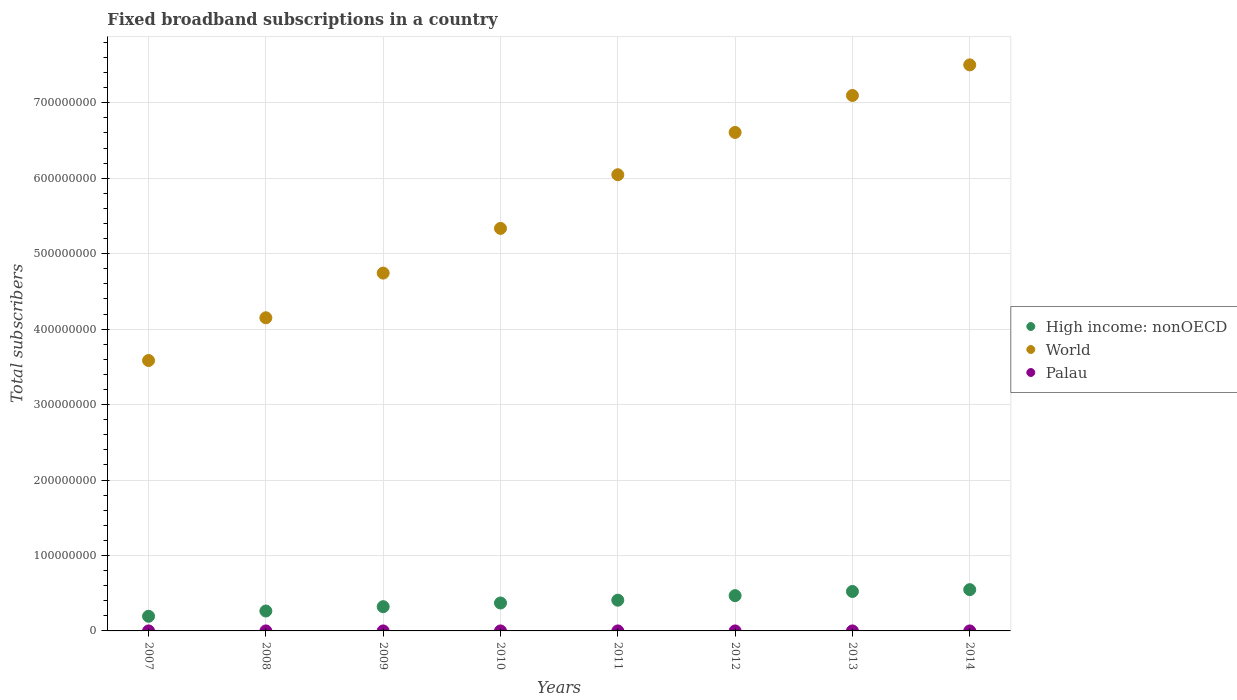What is the number of broadband subscriptions in World in 2011?
Provide a succinct answer. 6.05e+08. Across all years, what is the maximum number of broadband subscriptions in Palau?
Give a very brief answer. 1974. Across all years, what is the minimum number of broadband subscriptions in Palau?
Offer a terse response. 101. In which year was the number of broadband subscriptions in Palau maximum?
Give a very brief answer. 2014. What is the total number of broadband subscriptions in Palau in the graph?
Your response must be concise. 5788. What is the difference between the number of broadband subscriptions in World in 2011 and that in 2014?
Provide a short and direct response. -1.46e+08. What is the difference between the number of broadband subscriptions in World in 2007 and the number of broadband subscriptions in High income: nonOECD in 2009?
Ensure brevity in your answer.  3.26e+08. What is the average number of broadband subscriptions in Palau per year?
Keep it short and to the point. 723.5. In the year 2014, what is the difference between the number of broadband subscriptions in High income: nonOECD and number of broadband subscriptions in Palau?
Provide a short and direct response. 5.47e+07. What is the ratio of the number of broadband subscriptions in World in 2012 to that in 2014?
Your response must be concise. 0.88. What is the difference between the highest and the second highest number of broadband subscriptions in High income: nonOECD?
Provide a short and direct response. 2.42e+06. What is the difference between the highest and the lowest number of broadband subscriptions in Palau?
Your response must be concise. 1873. How many dotlines are there?
Your response must be concise. 3. How many years are there in the graph?
Keep it short and to the point. 8. Does the graph contain any zero values?
Give a very brief answer. No. Where does the legend appear in the graph?
Your response must be concise. Center right. How many legend labels are there?
Make the answer very short. 3. What is the title of the graph?
Provide a short and direct response. Fixed broadband subscriptions in a country. What is the label or title of the Y-axis?
Provide a short and direct response. Total subscribers. What is the Total subscribers in High income: nonOECD in 2007?
Offer a very short reply. 1.94e+07. What is the Total subscribers in World in 2007?
Provide a succinct answer. 3.58e+08. What is the Total subscribers in Palau in 2007?
Offer a terse response. 101. What is the Total subscribers of High income: nonOECD in 2008?
Your answer should be compact. 2.64e+07. What is the Total subscribers of World in 2008?
Give a very brief answer. 4.15e+08. What is the Total subscribers in Palau in 2008?
Keep it short and to the point. 111. What is the Total subscribers in High income: nonOECD in 2009?
Keep it short and to the point. 3.21e+07. What is the Total subscribers of World in 2009?
Your response must be concise. 4.74e+08. What is the Total subscribers of Palau in 2009?
Give a very brief answer. 142. What is the Total subscribers in High income: nonOECD in 2010?
Keep it short and to the point. 3.70e+07. What is the Total subscribers of World in 2010?
Ensure brevity in your answer.  5.33e+08. What is the Total subscribers in Palau in 2010?
Your answer should be compact. 239. What is the Total subscribers of High income: nonOECD in 2011?
Provide a succinct answer. 4.07e+07. What is the Total subscribers of World in 2011?
Make the answer very short. 6.05e+08. What is the Total subscribers in Palau in 2011?
Make the answer very short. 518. What is the Total subscribers of High income: nonOECD in 2012?
Provide a succinct answer. 4.67e+07. What is the Total subscribers of World in 2012?
Provide a short and direct response. 6.61e+08. What is the Total subscribers of Palau in 2012?
Provide a succinct answer. 898. What is the Total subscribers in High income: nonOECD in 2013?
Your response must be concise. 5.23e+07. What is the Total subscribers of World in 2013?
Provide a short and direct response. 7.10e+08. What is the Total subscribers of Palau in 2013?
Make the answer very short. 1805. What is the Total subscribers of High income: nonOECD in 2014?
Make the answer very short. 5.47e+07. What is the Total subscribers of World in 2014?
Ensure brevity in your answer.  7.50e+08. What is the Total subscribers of Palau in 2014?
Provide a succinct answer. 1974. Across all years, what is the maximum Total subscribers of High income: nonOECD?
Offer a very short reply. 5.47e+07. Across all years, what is the maximum Total subscribers in World?
Your answer should be compact. 7.50e+08. Across all years, what is the maximum Total subscribers of Palau?
Offer a terse response. 1974. Across all years, what is the minimum Total subscribers of High income: nonOECD?
Offer a terse response. 1.94e+07. Across all years, what is the minimum Total subscribers of World?
Provide a short and direct response. 3.58e+08. Across all years, what is the minimum Total subscribers of Palau?
Keep it short and to the point. 101. What is the total Total subscribers of High income: nonOECD in the graph?
Offer a very short reply. 3.09e+08. What is the total Total subscribers of World in the graph?
Your response must be concise. 4.51e+09. What is the total Total subscribers in Palau in the graph?
Offer a terse response. 5788. What is the difference between the Total subscribers of High income: nonOECD in 2007 and that in 2008?
Your answer should be very brief. -6.99e+06. What is the difference between the Total subscribers of World in 2007 and that in 2008?
Offer a terse response. -5.66e+07. What is the difference between the Total subscribers of High income: nonOECD in 2007 and that in 2009?
Offer a very short reply. -1.27e+07. What is the difference between the Total subscribers in World in 2007 and that in 2009?
Your answer should be compact. -1.16e+08. What is the difference between the Total subscribers in Palau in 2007 and that in 2009?
Give a very brief answer. -41. What is the difference between the Total subscribers of High income: nonOECD in 2007 and that in 2010?
Provide a succinct answer. -1.76e+07. What is the difference between the Total subscribers in World in 2007 and that in 2010?
Your response must be concise. -1.75e+08. What is the difference between the Total subscribers in Palau in 2007 and that in 2010?
Your response must be concise. -138. What is the difference between the Total subscribers of High income: nonOECD in 2007 and that in 2011?
Provide a succinct answer. -2.13e+07. What is the difference between the Total subscribers of World in 2007 and that in 2011?
Provide a succinct answer. -2.46e+08. What is the difference between the Total subscribers in Palau in 2007 and that in 2011?
Provide a succinct answer. -417. What is the difference between the Total subscribers of High income: nonOECD in 2007 and that in 2012?
Offer a terse response. -2.73e+07. What is the difference between the Total subscribers of World in 2007 and that in 2012?
Provide a succinct answer. -3.02e+08. What is the difference between the Total subscribers of Palau in 2007 and that in 2012?
Give a very brief answer. -797. What is the difference between the Total subscribers in High income: nonOECD in 2007 and that in 2013?
Give a very brief answer. -3.29e+07. What is the difference between the Total subscribers of World in 2007 and that in 2013?
Provide a succinct answer. -3.51e+08. What is the difference between the Total subscribers of Palau in 2007 and that in 2013?
Your response must be concise. -1704. What is the difference between the Total subscribers of High income: nonOECD in 2007 and that in 2014?
Your answer should be compact. -3.53e+07. What is the difference between the Total subscribers of World in 2007 and that in 2014?
Offer a very short reply. -3.92e+08. What is the difference between the Total subscribers of Palau in 2007 and that in 2014?
Your answer should be very brief. -1873. What is the difference between the Total subscribers of High income: nonOECD in 2008 and that in 2009?
Make the answer very short. -5.73e+06. What is the difference between the Total subscribers of World in 2008 and that in 2009?
Your response must be concise. -5.92e+07. What is the difference between the Total subscribers in Palau in 2008 and that in 2009?
Make the answer very short. -31. What is the difference between the Total subscribers in High income: nonOECD in 2008 and that in 2010?
Make the answer very short. -1.06e+07. What is the difference between the Total subscribers in World in 2008 and that in 2010?
Your answer should be very brief. -1.18e+08. What is the difference between the Total subscribers of Palau in 2008 and that in 2010?
Give a very brief answer. -128. What is the difference between the Total subscribers in High income: nonOECD in 2008 and that in 2011?
Your answer should be compact. -1.43e+07. What is the difference between the Total subscribers in World in 2008 and that in 2011?
Give a very brief answer. -1.90e+08. What is the difference between the Total subscribers of Palau in 2008 and that in 2011?
Ensure brevity in your answer.  -407. What is the difference between the Total subscribers in High income: nonOECD in 2008 and that in 2012?
Offer a very short reply. -2.03e+07. What is the difference between the Total subscribers in World in 2008 and that in 2012?
Give a very brief answer. -2.46e+08. What is the difference between the Total subscribers in Palau in 2008 and that in 2012?
Ensure brevity in your answer.  -787. What is the difference between the Total subscribers in High income: nonOECD in 2008 and that in 2013?
Your answer should be very brief. -2.59e+07. What is the difference between the Total subscribers in World in 2008 and that in 2013?
Ensure brevity in your answer.  -2.95e+08. What is the difference between the Total subscribers of Palau in 2008 and that in 2013?
Offer a terse response. -1694. What is the difference between the Total subscribers of High income: nonOECD in 2008 and that in 2014?
Your answer should be compact. -2.83e+07. What is the difference between the Total subscribers in World in 2008 and that in 2014?
Offer a very short reply. -3.35e+08. What is the difference between the Total subscribers in Palau in 2008 and that in 2014?
Make the answer very short. -1863. What is the difference between the Total subscribers in High income: nonOECD in 2009 and that in 2010?
Make the answer very short. -4.88e+06. What is the difference between the Total subscribers of World in 2009 and that in 2010?
Offer a very short reply. -5.92e+07. What is the difference between the Total subscribers in Palau in 2009 and that in 2010?
Make the answer very short. -97. What is the difference between the Total subscribers in High income: nonOECD in 2009 and that in 2011?
Your answer should be compact. -8.60e+06. What is the difference between the Total subscribers in World in 2009 and that in 2011?
Offer a very short reply. -1.30e+08. What is the difference between the Total subscribers in Palau in 2009 and that in 2011?
Provide a succinct answer. -376. What is the difference between the Total subscribers of High income: nonOECD in 2009 and that in 2012?
Keep it short and to the point. -1.46e+07. What is the difference between the Total subscribers of World in 2009 and that in 2012?
Offer a terse response. -1.86e+08. What is the difference between the Total subscribers of Palau in 2009 and that in 2012?
Give a very brief answer. -756. What is the difference between the Total subscribers of High income: nonOECD in 2009 and that in 2013?
Keep it short and to the point. -2.02e+07. What is the difference between the Total subscribers of World in 2009 and that in 2013?
Give a very brief answer. -2.35e+08. What is the difference between the Total subscribers of Palau in 2009 and that in 2013?
Your answer should be compact. -1663. What is the difference between the Total subscribers of High income: nonOECD in 2009 and that in 2014?
Make the answer very short. -2.26e+07. What is the difference between the Total subscribers of World in 2009 and that in 2014?
Your response must be concise. -2.76e+08. What is the difference between the Total subscribers in Palau in 2009 and that in 2014?
Provide a short and direct response. -1832. What is the difference between the Total subscribers in High income: nonOECD in 2010 and that in 2011?
Offer a terse response. -3.72e+06. What is the difference between the Total subscribers in World in 2010 and that in 2011?
Offer a terse response. -7.11e+07. What is the difference between the Total subscribers of Palau in 2010 and that in 2011?
Your answer should be very brief. -279. What is the difference between the Total subscribers of High income: nonOECD in 2010 and that in 2012?
Offer a very short reply. -9.74e+06. What is the difference between the Total subscribers of World in 2010 and that in 2012?
Make the answer very short. -1.27e+08. What is the difference between the Total subscribers of Palau in 2010 and that in 2012?
Give a very brief answer. -659. What is the difference between the Total subscribers in High income: nonOECD in 2010 and that in 2013?
Offer a terse response. -1.53e+07. What is the difference between the Total subscribers in World in 2010 and that in 2013?
Provide a succinct answer. -1.76e+08. What is the difference between the Total subscribers in Palau in 2010 and that in 2013?
Provide a short and direct response. -1566. What is the difference between the Total subscribers of High income: nonOECD in 2010 and that in 2014?
Keep it short and to the point. -1.77e+07. What is the difference between the Total subscribers of World in 2010 and that in 2014?
Your response must be concise. -2.17e+08. What is the difference between the Total subscribers in Palau in 2010 and that in 2014?
Keep it short and to the point. -1735. What is the difference between the Total subscribers in High income: nonOECD in 2011 and that in 2012?
Ensure brevity in your answer.  -6.02e+06. What is the difference between the Total subscribers in World in 2011 and that in 2012?
Your answer should be compact. -5.61e+07. What is the difference between the Total subscribers of Palau in 2011 and that in 2012?
Keep it short and to the point. -380. What is the difference between the Total subscribers of High income: nonOECD in 2011 and that in 2013?
Ensure brevity in your answer.  -1.16e+07. What is the difference between the Total subscribers of World in 2011 and that in 2013?
Your response must be concise. -1.05e+08. What is the difference between the Total subscribers in Palau in 2011 and that in 2013?
Provide a succinct answer. -1287. What is the difference between the Total subscribers in High income: nonOECD in 2011 and that in 2014?
Provide a succinct answer. -1.40e+07. What is the difference between the Total subscribers of World in 2011 and that in 2014?
Offer a terse response. -1.46e+08. What is the difference between the Total subscribers in Palau in 2011 and that in 2014?
Make the answer very short. -1456. What is the difference between the Total subscribers in High income: nonOECD in 2012 and that in 2013?
Offer a terse response. -5.55e+06. What is the difference between the Total subscribers in World in 2012 and that in 2013?
Your answer should be very brief. -4.90e+07. What is the difference between the Total subscribers of Palau in 2012 and that in 2013?
Ensure brevity in your answer.  -907. What is the difference between the Total subscribers in High income: nonOECD in 2012 and that in 2014?
Offer a very short reply. -7.97e+06. What is the difference between the Total subscribers in World in 2012 and that in 2014?
Ensure brevity in your answer.  -8.95e+07. What is the difference between the Total subscribers of Palau in 2012 and that in 2014?
Provide a succinct answer. -1076. What is the difference between the Total subscribers in High income: nonOECD in 2013 and that in 2014?
Your response must be concise. -2.42e+06. What is the difference between the Total subscribers of World in 2013 and that in 2014?
Offer a terse response. -4.05e+07. What is the difference between the Total subscribers of Palau in 2013 and that in 2014?
Offer a terse response. -169. What is the difference between the Total subscribers in High income: nonOECD in 2007 and the Total subscribers in World in 2008?
Offer a very short reply. -3.96e+08. What is the difference between the Total subscribers in High income: nonOECD in 2007 and the Total subscribers in Palau in 2008?
Offer a terse response. 1.94e+07. What is the difference between the Total subscribers of World in 2007 and the Total subscribers of Palau in 2008?
Make the answer very short. 3.58e+08. What is the difference between the Total subscribers in High income: nonOECD in 2007 and the Total subscribers in World in 2009?
Keep it short and to the point. -4.55e+08. What is the difference between the Total subscribers of High income: nonOECD in 2007 and the Total subscribers of Palau in 2009?
Your response must be concise. 1.94e+07. What is the difference between the Total subscribers of World in 2007 and the Total subscribers of Palau in 2009?
Provide a succinct answer. 3.58e+08. What is the difference between the Total subscribers of High income: nonOECD in 2007 and the Total subscribers of World in 2010?
Provide a short and direct response. -5.14e+08. What is the difference between the Total subscribers in High income: nonOECD in 2007 and the Total subscribers in Palau in 2010?
Ensure brevity in your answer.  1.94e+07. What is the difference between the Total subscribers of World in 2007 and the Total subscribers of Palau in 2010?
Your answer should be compact. 3.58e+08. What is the difference between the Total subscribers in High income: nonOECD in 2007 and the Total subscribers in World in 2011?
Provide a short and direct response. -5.85e+08. What is the difference between the Total subscribers in High income: nonOECD in 2007 and the Total subscribers in Palau in 2011?
Give a very brief answer. 1.94e+07. What is the difference between the Total subscribers of World in 2007 and the Total subscribers of Palau in 2011?
Your answer should be very brief. 3.58e+08. What is the difference between the Total subscribers of High income: nonOECD in 2007 and the Total subscribers of World in 2012?
Make the answer very short. -6.41e+08. What is the difference between the Total subscribers of High income: nonOECD in 2007 and the Total subscribers of Palau in 2012?
Ensure brevity in your answer.  1.94e+07. What is the difference between the Total subscribers in World in 2007 and the Total subscribers in Palau in 2012?
Provide a short and direct response. 3.58e+08. What is the difference between the Total subscribers in High income: nonOECD in 2007 and the Total subscribers in World in 2013?
Give a very brief answer. -6.90e+08. What is the difference between the Total subscribers of High income: nonOECD in 2007 and the Total subscribers of Palau in 2013?
Offer a very short reply. 1.94e+07. What is the difference between the Total subscribers in World in 2007 and the Total subscribers in Palau in 2013?
Keep it short and to the point. 3.58e+08. What is the difference between the Total subscribers of High income: nonOECD in 2007 and the Total subscribers of World in 2014?
Provide a succinct answer. -7.31e+08. What is the difference between the Total subscribers of High income: nonOECD in 2007 and the Total subscribers of Palau in 2014?
Offer a very short reply. 1.94e+07. What is the difference between the Total subscribers in World in 2007 and the Total subscribers in Palau in 2014?
Provide a short and direct response. 3.58e+08. What is the difference between the Total subscribers in High income: nonOECD in 2008 and the Total subscribers in World in 2009?
Make the answer very short. -4.48e+08. What is the difference between the Total subscribers of High income: nonOECD in 2008 and the Total subscribers of Palau in 2009?
Offer a terse response. 2.64e+07. What is the difference between the Total subscribers of World in 2008 and the Total subscribers of Palau in 2009?
Offer a very short reply. 4.15e+08. What is the difference between the Total subscribers of High income: nonOECD in 2008 and the Total subscribers of World in 2010?
Keep it short and to the point. -5.07e+08. What is the difference between the Total subscribers in High income: nonOECD in 2008 and the Total subscribers in Palau in 2010?
Offer a very short reply. 2.64e+07. What is the difference between the Total subscribers of World in 2008 and the Total subscribers of Palau in 2010?
Ensure brevity in your answer.  4.15e+08. What is the difference between the Total subscribers in High income: nonOECD in 2008 and the Total subscribers in World in 2011?
Your answer should be compact. -5.78e+08. What is the difference between the Total subscribers in High income: nonOECD in 2008 and the Total subscribers in Palau in 2011?
Your response must be concise. 2.64e+07. What is the difference between the Total subscribers of World in 2008 and the Total subscribers of Palau in 2011?
Your response must be concise. 4.15e+08. What is the difference between the Total subscribers of High income: nonOECD in 2008 and the Total subscribers of World in 2012?
Offer a very short reply. -6.34e+08. What is the difference between the Total subscribers in High income: nonOECD in 2008 and the Total subscribers in Palau in 2012?
Your response must be concise. 2.64e+07. What is the difference between the Total subscribers in World in 2008 and the Total subscribers in Palau in 2012?
Provide a succinct answer. 4.15e+08. What is the difference between the Total subscribers in High income: nonOECD in 2008 and the Total subscribers in World in 2013?
Make the answer very short. -6.83e+08. What is the difference between the Total subscribers in High income: nonOECD in 2008 and the Total subscribers in Palau in 2013?
Your response must be concise. 2.64e+07. What is the difference between the Total subscribers of World in 2008 and the Total subscribers of Palau in 2013?
Give a very brief answer. 4.15e+08. What is the difference between the Total subscribers of High income: nonOECD in 2008 and the Total subscribers of World in 2014?
Provide a short and direct response. -7.24e+08. What is the difference between the Total subscribers in High income: nonOECD in 2008 and the Total subscribers in Palau in 2014?
Offer a very short reply. 2.64e+07. What is the difference between the Total subscribers in World in 2008 and the Total subscribers in Palau in 2014?
Keep it short and to the point. 4.15e+08. What is the difference between the Total subscribers of High income: nonOECD in 2009 and the Total subscribers of World in 2010?
Your answer should be compact. -5.01e+08. What is the difference between the Total subscribers of High income: nonOECD in 2009 and the Total subscribers of Palau in 2010?
Give a very brief answer. 3.21e+07. What is the difference between the Total subscribers in World in 2009 and the Total subscribers in Palau in 2010?
Offer a very short reply. 4.74e+08. What is the difference between the Total subscribers of High income: nonOECD in 2009 and the Total subscribers of World in 2011?
Your answer should be compact. -5.72e+08. What is the difference between the Total subscribers of High income: nonOECD in 2009 and the Total subscribers of Palau in 2011?
Your response must be concise. 3.21e+07. What is the difference between the Total subscribers of World in 2009 and the Total subscribers of Palau in 2011?
Your answer should be very brief. 4.74e+08. What is the difference between the Total subscribers of High income: nonOECD in 2009 and the Total subscribers of World in 2012?
Give a very brief answer. -6.29e+08. What is the difference between the Total subscribers in High income: nonOECD in 2009 and the Total subscribers in Palau in 2012?
Your answer should be very brief. 3.21e+07. What is the difference between the Total subscribers of World in 2009 and the Total subscribers of Palau in 2012?
Your answer should be compact. 4.74e+08. What is the difference between the Total subscribers of High income: nonOECD in 2009 and the Total subscribers of World in 2013?
Provide a short and direct response. -6.78e+08. What is the difference between the Total subscribers of High income: nonOECD in 2009 and the Total subscribers of Palau in 2013?
Offer a terse response. 3.21e+07. What is the difference between the Total subscribers of World in 2009 and the Total subscribers of Palau in 2013?
Give a very brief answer. 4.74e+08. What is the difference between the Total subscribers in High income: nonOECD in 2009 and the Total subscribers in World in 2014?
Give a very brief answer. -7.18e+08. What is the difference between the Total subscribers in High income: nonOECD in 2009 and the Total subscribers in Palau in 2014?
Keep it short and to the point. 3.21e+07. What is the difference between the Total subscribers of World in 2009 and the Total subscribers of Palau in 2014?
Your answer should be very brief. 4.74e+08. What is the difference between the Total subscribers in High income: nonOECD in 2010 and the Total subscribers in World in 2011?
Make the answer very short. -5.68e+08. What is the difference between the Total subscribers in High income: nonOECD in 2010 and the Total subscribers in Palau in 2011?
Give a very brief answer. 3.70e+07. What is the difference between the Total subscribers in World in 2010 and the Total subscribers in Palau in 2011?
Provide a succinct answer. 5.33e+08. What is the difference between the Total subscribers of High income: nonOECD in 2010 and the Total subscribers of World in 2012?
Provide a succinct answer. -6.24e+08. What is the difference between the Total subscribers in High income: nonOECD in 2010 and the Total subscribers in Palau in 2012?
Offer a terse response. 3.70e+07. What is the difference between the Total subscribers in World in 2010 and the Total subscribers in Palau in 2012?
Your answer should be compact. 5.33e+08. What is the difference between the Total subscribers in High income: nonOECD in 2010 and the Total subscribers in World in 2013?
Your answer should be compact. -6.73e+08. What is the difference between the Total subscribers of High income: nonOECD in 2010 and the Total subscribers of Palau in 2013?
Offer a terse response. 3.70e+07. What is the difference between the Total subscribers in World in 2010 and the Total subscribers in Palau in 2013?
Offer a very short reply. 5.33e+08. What is the difference between the Total subscribers of High income: nonOECD in 2010 and the Total subscribers of World in 2014?
Offer a terse response. -7.13e+08. What is the difference between the Total subscribers of High income: nonOECD in 2010 and the Total subscribers of Palau in 2014?
Your response must be concise. 3.70e+07. What is the difference between the Total subscribers of World in 2010 and the Total subscribers of Palau in 2014?
Keep it short and to the point. 5.33e+08. What is the difference between the Total subscribers in High income: nonOECD in 2011 and the Total subscribers in World in 2012?
Ensure brevity in your answer.  -6.20e+08. What is the difference between the Total subscribers of High income: nonOECD in 2011 and the Total subscribers of Palau in 2012?
Ensure brevity in your answer.  4.07e+07. What is the difference between the Total subscribers of World in 2011 and the Total subscribers of Palau in 2012?
Offer a very short reply. 6.05e+08. What is the difference between the Total subscribers of High income: nonOECD in 2011 and the Total subscribers of World in 2013?
Make the answer very short. -6.69e+08. What is the difference between the Total subscribers in High income: nonOECD in 2011 and the Total subscribers in Palau in 2013?
Offer a terse response. 4.07e+07. What is the difference between the Total subscribers in World in 2011 and the Total subscribers in Palau in 2013?
Provide a short and direct response. 6.05e+08. What is the difference between the Total subscribers of High income: nonOECD in 2011 and the Total subscribers of World in 2014?
Provide a short and direct response. -7.09e+08. What is the difference between the Total subscribers of High income: nonOECD in 2011 and the Total subscribers of Palau in 2014?
Make the answer very short. 4.07e+07. What is the difference between the Total subscribers in World in 2011 and the Total subscribers in Palau in 2014?
Your answer should be compact. 6.05e+08. What is the difference between the Total subscribers in High income: nonOECD in 2012 and the Total subscribers in World in 2013?
Ensure brevity in your answer.  -6.63e+08. What is the difference between the Total subscribers of High income: nonOECD in 2012 and the Total subscribers of Palau in 2013?
Provide a short and direct response. 4.67e+07. What is the difference between the Total subscribers of World in 2012 and the Total subscribers of Palau in 2013?
Offer a terse response. 6.61e+08. What is the difference between the Total subscribers in High income: nonOECD in 2012 and the Total subscribers in World in 2014?
Your answer should be compact. -7.03e+08. What is the difference between the Total subscribers in High income: nonOECD in 2012 and the Total subscribers in Palau in 2014?
Offer a terse response. 4.67e+07. What is the difference between the Total subscribers of World in 2012 and the Total subscribers of Palau in 2014?
Ensure brevity in your answer.  6.61e+08. What is the difference between the Total subscribers in High income: nonOECD in 2013 and the Total subscribers in World in 2014?
Your response must be concise. -6.98e+08. What is the difference between the Total subscribers of High income: nonOECD in 2013 and the Total subscribers of Palau in 2014?
Your answer should be very brief. 5.23e+07. What is the difference between the Total subscribers in World in 2013 and the Total subscribers in Palau in 2014?
Offer a terse response. 7.10e+08. What is the average Total subscribers in High income: nonOECD per year?
Provide a short and direct response. 3.87e+07. What is the average Total subscribers in World per year?
Keep it short and to the point. 5.63e+08. What is the average Total subscribers in Palau per year?
Keep it short and to the point. 723.5. In the year 2007, what is the difference between the Total subscribers in High income: nonOECD and Total subscribers in World?
Provide a succinct answer. -3.39e+08. In the year 2007, what is the difference between the Total subscribers of High income: nonOECD and Total subscribers of Palau?
Provide a succinct answer. 1.94e+07. In the year 2007, what is the difference between the Total subscribers of World and Total subscribers of Palau?
Your response must be concise. 3.58e+08. In the year 2008, what is the difference between the Total subscribers of High income: nonOECD and Total subscribers of World?
Your answer should be very brief. -3.89e+08. In the year 2008, what is the difference between the Total subscribers of High income: nonOECD and Total subscribers of Palau?
Give a very brief answer. 2.64e+07. In the year 2008, what is the difference between the Total subscribers in World and Total subscribers in Palau?
Your response must be concise. 4.15e+08. In the year 2009, what is the difference between the Total subscribers of High income: nonOECD and Total subscribers of World?
Make the answer very short. -4.42e+08. In the year 2009, what is the difference between the Total subscribers in High income: nonOECD and Total subscribers in Palau?
Provide a short and direct response. 3.21e+07. In the year 2009, what is the difference between the Total subscribers in World and Total subscribers in Palau?
Your answer should be compact. 4.74e+08. In the year 2010, what is the difference between the Total subscribers of High income: nonOECD and Total subscribers of World?
Give a very brief answer. -4.96e+08. In the year 2010, what is the difference between the Total subscribers of High income: nonOECD and Total subscribers of Palau?
Provide a succinct answer. 3.70e+07. In the year 2010, what is the difference between the Total subscribers in World and Total subscribers in Palau?
Your answer should be very brief. 5.33e+08. In the year 2011, what is the difference between the Total subscribers in High income: nonOECD and Total subscribers in World?
Ensure brevity in your answer.  -5.64e+08. In the year 2011, what is the difference between the Total subscribers of High income: nonOECD and Total subscribers of Palau?
Provide a short and direct response. 4.07e+07. In the year 2011, what is the difference between the Total subscribers in World and Total subscribers in Palau?
Offer a terse response. 6.05e+08. In the year 2012, what is the difference between the Total subscribers of High income: nonOECD and Total subscribers of World?
Keep it short and to the point. -6.14e+08. In the year 2012, what is the difference between the Total subscribers in High income: nonOECD and Total subscribers in Palau?
Your answer should be compact. 4.67e+07. In the year 2012, what is the difference between the Total subscribers in World and Total subscribers in Palau?
Offer a terse response. 6.61e+08. In the year 2013, what is the difference between the Total subscribers in High income: nonOECD and Total subscribers in World?
Provide a short and direct response. -6.57e+08. In the year 2013, what is the difference between the Total subscribers in High income: nonOECD and Total subscribers in Palau?
Your answer should be compact. 5.23e+07. In the year 2013, what is the difference between the Total subscribers in World and Total subscribers in Palau?
Make the answer very short. 7.10e+08. In the year 2014, what is the difference between the Total subscribers of High income: nonOECD and Total subscribers of World?
Give a very brief answer. -6.95e+08. In the year 2014, what is the difference between the Total subscribers in High income: nonOECD and Total subscribers in Palau?
Provide a succinct answer. 5.47e+07. In the year 2014, what is the difference between the Total subscribers in World and Total subscribers in Palau?
Provide a succinct answer. 7.50e+08. What is the ratio of the Total subscribers in High income: nonOECD in 2007 to that in 2008?
Keep it short and to the point. 0.74. What is the ratio of the Total subscribers in World in 2007 to that in 2008?
Offer a terse response. 0.86. What is the ratio of the Total subscribers of Palau in 2007 to that in 2008?
Provide a succinct answer. 0.91. What is the ratio of the Total subscribers in High income: nonOECD in 2007 to that in 2009?
Your answer should be compact. 0.6. What is the ratio of the Total subscribers in World in 2007 to that in 2009?
Provide a succinct answer. 0.76. What is the ratio of the Total subscribers of Palau in 2007 to that in 2009?
Make the answer very short. 0.71. What is the ratio of the Total subscribers in High income: nonOECD in 2007 to that in 2010?
Offer a very short reply. 0.52. What is the ratio of the Total subscribers of World in 2007 to that in 2010?
Your answer should be very brief. 0.67. What is the ratio of the Total subscribers in Palau in 2007 to that in 2010?
Your answer should be compact. 0.42. What is the ratio of the Total subscribers of High income: nonOECD in 2007 to that in 2011?
Provide a succinct answer. 0.48. What is the ratio of the Total subscribers in World in 2007 to that in 2011?
Your answer should be compact. 0.59. What is the ratio of the Total subscribers in Palau in 2007 to that in 2011?
Ensure brevity in your answer.  0.2. What is the ratio of the Total subscribers of High income: nonOECD in 2007 to that in 2012?
Your answer should be compact. 0.42. What is the ratio of the Total subscribers of World in 2007 to that in 2012?
Give a very brief answer. 0.54. What is the ratio of the Total subscribers in Palau in 2007 to that in 2012?
Offer a terse response. 0.11. What is the ratio of the Total subscribers of High income: nonOECD in 2007 to that in 2013?
Offer a terse response. 0.37. What is the ratio of the Total subscribers in World in 2007 to that in 2013?
Provide a succinct answer. 0.51. What is the ratio of the Total subscribers of Palau in 2007 to that in 2013?
Your answer should be very brief. 0.06. What is the ratio of the Total subscribers of High income: nonOECD in 2007 to that in 2014?
Your answer should be compact. 0.35. What is the ratio of the Total subscribers in World in 2007 to that in 2014?
Provide a short and direct response. 0.48. What is the ratio of the Total subscribers in Palau in 2007 to that in 2014?
Your response must be concise. 0.05. What is the ratio of the Total subscribers of High income: nonOECD in 2008 to that in 2009?
Your response must be concise. 0.82. What is the ratio of the Total subscribers in World in 2008 to that in 2009?
Offer a very short reply. 0.88. What is the ratio of the Total subscribers of Palau in 2008 to that in 2009?
Keep it short and to the point. 0.78. What is the ratio of the Total subscribers in High income: nonOECD in 2008 to that in 2010?
Keep it short and to the point. 0.71. What is the ratio of the Total subscribers of World in 2008 to that in 2010?
Your answer should be compact. 0.78. What is the ratio of the Total subscribers of Palau in 2008 to that in 2010?
Offer a very short reply. 0.46. What is the ratio of the Total subscribers in High income: nonOECD in 2008 to that in 2011?
Your answer should be compact. 0.65. What is the ratio of the Total subscribers in World in 2008 to that in 2011?
Offer a very short reply. 0.69. What is the ratio of the Total subscribers of Palau in 2008 to that in 2011?
Provide a short and direct response. 0.21. What is the ratio of the Total subscribers in High income: nonOECD in 2008 to that in 2012?
Make the answer very short. 0.56. What is the ratio of the Total subscribers in World in 2008 to that in 2012?
Ensure brevity in your answer.  0.63. What is the ratio of the Total subscribers of Palau in 2008 to that in 2012?
Make the answer very short. 0.12. What is the ratio of the Total subscribers in High income: nonOECD in 2008 to that in 2013?
Ensure brevity in your answer.  0.5. What is the ratio of the Total subscribers of World in 2008 to that in 2013?
Provide a succinct answer. 0.58. What is the ratio of the Total subscribers of Palau in 2008 to that in 2013?
Keep it short and to the point. 0.06. What is the ratio of the Total subscribers in High income: nonOECD in 2008 to that in 2014?
Offer a terse response. 0.48. What is the ratio of the Total subscribers of World in 2008 to that in 2014?
Provide a succinct answer. 0.55. What is the ratio of the Total subscribers of Palau in 2008 to that in 2014?
Offer a very short reply. 0.06. What is the ratio of the Total subscribers in High income: nonOECD in 2009 to that in 2010?
Make the answer very short. 0.87. What is the ratio of the Total subscribers of World in 2009 to that in 2010?
Your response must be concise. 0.89. What is the ratio of the Total subscribers in Palau in 2009 to that in 2010?
Your answer should be compact. 0.59. What is the ratio of the Total subscribers of High income: nonOECD in 2009 to that in 2011?
Offer a terse response. 0.79. What is the ratio of the Total subscribers in World in 2009 to that in 2011?
Your answer should be very brief. 0.78. What is the ratio of the Total subscribers of Palau in 2009 to that in 2011?
Make the answer very short. 0.27. What is the ratio of the Total subscribers of High income: nonOECD in 2009 to that in 2012?
Offer a terse response. 0.69. What is the ratio of the Total subscribers in World in 2009 to that in 2012?
Your answer should be compact. 0.72. What is the ratio of the Total subscribers in Palau in 2009 to that in 2012?
Give a very brief answer. 0.16. What is the ratio of the Total subscribers of High income: nonOECD in 2009 to that in 2013?
Make the answer very short. 0.61. What is the ratio of the Total subscribers in World in 2009 to that in 2013?
Keep it short and to the point. 0.67. What is the ratio of the Total subscribers in Palau in 2009 to that in 2013?
Your response must be concise. 0.08. What is the ratio of the Total subscribers of High income: nonOECD in 2009 to that in 2014?
Your answer should be compact. 0.59. What is the ratio of the Total subscribers of World in 2009 to that in 2014?
Your answer should be very brief. 0.63. What is the ratio of the Total subscribers of Palau in 2009 to that in 2014?
Your answer should be very brief. 0.07. What is the ratio of the Total subscribers of High income: nonOECD in 2010 to that in 2011?
Provide a succinct answer. 0.91. What is the ratio of the Total subscribers of World in 2010 to that in 2011?
Your answer should be compact. 0.88. What is the ratio of the Total subscribers in Palau in 2010 to that in 2011?
Provide a succinct answer. 0.46. What is the ratio of the Total subscribers in High income: nonOECD in 2010 to that in 2012?
Make the answer very short. 0.79. What is the ratio of the Total subscribers in World in 2010 to that in 2012?
Your answer should be very brief. 0.81. What is the ratio of the Total subscribers in Palau in 2010 to that in 2012?
Provide a short and direct response. 0.27. What is the ratio of the Total subscribers of High income: nonOECD in 2010 to that in 2013?
Ensure brevity in your answer.  0.71. What is the ratio of the Total subscribers of World in 2010 to that in 2013?
Keep it short and to the point. 0.75. What is the ratio of the Total subscribers in Palau in 2010 to that in 2013?
Your answer should be compact. 0.13. What is the ratio of the Total subscribers of High income: nonOECD in 2010 to that in 2014?
Your answer should be very brief. 0.68. What is the ratio of the Total subscribers of World in 2010 to that in 2014?
Ensure brevity in your answer.  0.71. What is the ratio of the Total subscribers in Palau in 2010 to that in 2014?
Make the answer very short. 0.12. What is the ratio of the Total subscribers in High income: nonOECD in 2011 to that in 2012?
Offer a terse response. 0.87. What is the ratio of the Total subscribers of World in 2011 to that in 2012?
Provide a short and direct response. 0.92. What is the ratio of the Total subscribers in Palau in 2011 to that in 2012?
Make the answer very short. 0.58. What is the ratio of the Total subscribers of High income: nonOECD in 2011 to that in 2013?
Offer a terse response. 0.78. What is the ratio of the Total subscribers in World in 2011 to that in 2013?
Your answer should be compact. 0.85. What is the ratio of the Total subscribers in Palau in 2011 to that in 2013?
Provide a short and direct response. 0.29. What is the ratio of the Total subscribers of High income: nonOECD in 2011 to that in 2014?
Your response must be concise. 0.74. What is the ratio of the Total subscribers of World in 2011 to that in 2014?
Your answer should be compact. 0.81. What is the ratio of the Total subscribers of Palau in 2011 to that in 2014?
Offer a terse response. 0.26. What is the ratio of the Total subscribers of High income: nonOECD in 2012 to that in 2013?
Keep it short and to the point. 0.89. What is the ratio of the Total subscribers in Palau in 2012 to that in 2013?
Provide a succinct answer. 0.5. What is the ratio of the Total subscribers in High income: nonOECD in 2012 to that in 2014?
Your response must be concise. 0.85. What is the ratio of the Total subscribers in World in 2012 to that in 2014?
Offer a terse response. 0.88. What is the ratio of the Total subscribers of Palau in 2012 to that in 2014?
Give a very brief answer. 0.45. What is the ratio of the Total subscribers in High income: nonOECD in 2013 to that in 2014?
Give a very brief answer. 0.96. What is the ratio of the Total subscribers in World in 2013 to that in 2014?
Provide a succinct answer. 0.95. What is the ratio of the Total subscribers of Palau in 2013 to that in 2014?
Keep it short and to the point. 0.91. What is the difference between the highest and the second highest Total subscribers in High income: nonOECD?
Make the answer very short. 2.42e+06. What is the difference between the highest and the second highest Total subscribers in World?
Keep it short and to the point. 4.05e+07. What is the difference between the highest and the second highest Total subscribers in Palau?
Keep it short and to the point. 169. What is the difference between the highest and the lowest Total subscribers of High income: nonOECD?
Your answer should be very brief. 3.53e+07. What is the difference between the highest and the lowest Total subscribers in World?
Offer a very short reply. 3.92e+08. What is the difference between the highest and the lowest Total subscribers in Palau?
Ensure brevity in your answer.  1873. 